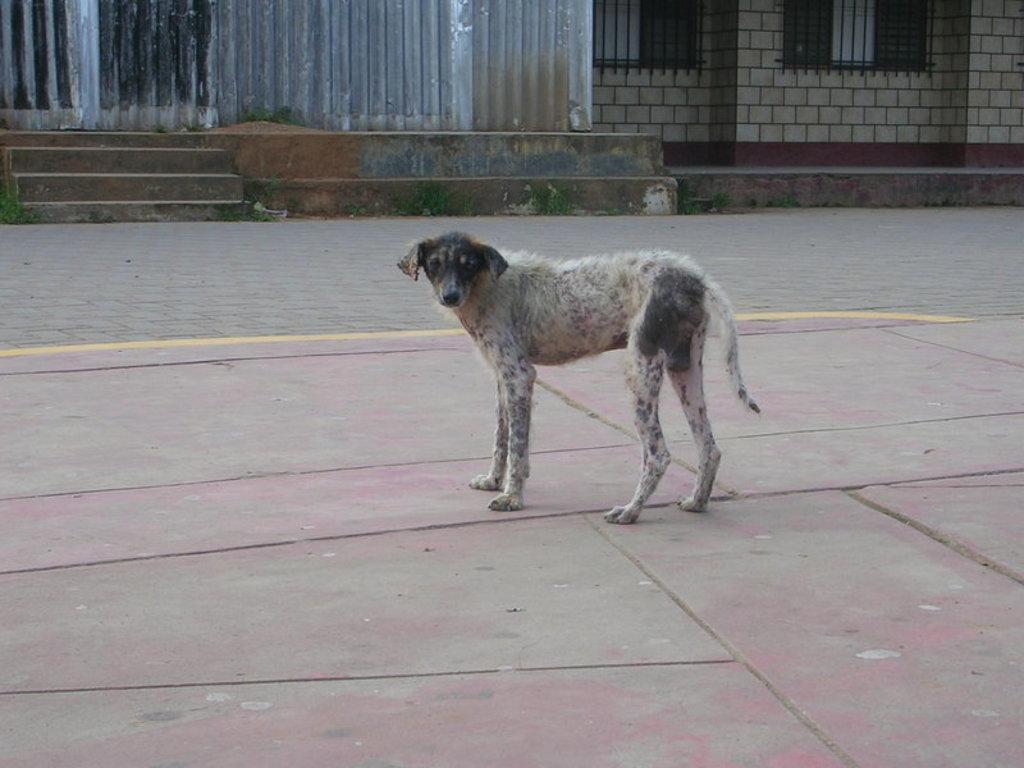Describe this image in one or two sentences. In this image we can see a dog is standing on the surface. In the background we can see the wall, windows, welded mesh wires, steps and on the left side at the top we can see metal sheets. 